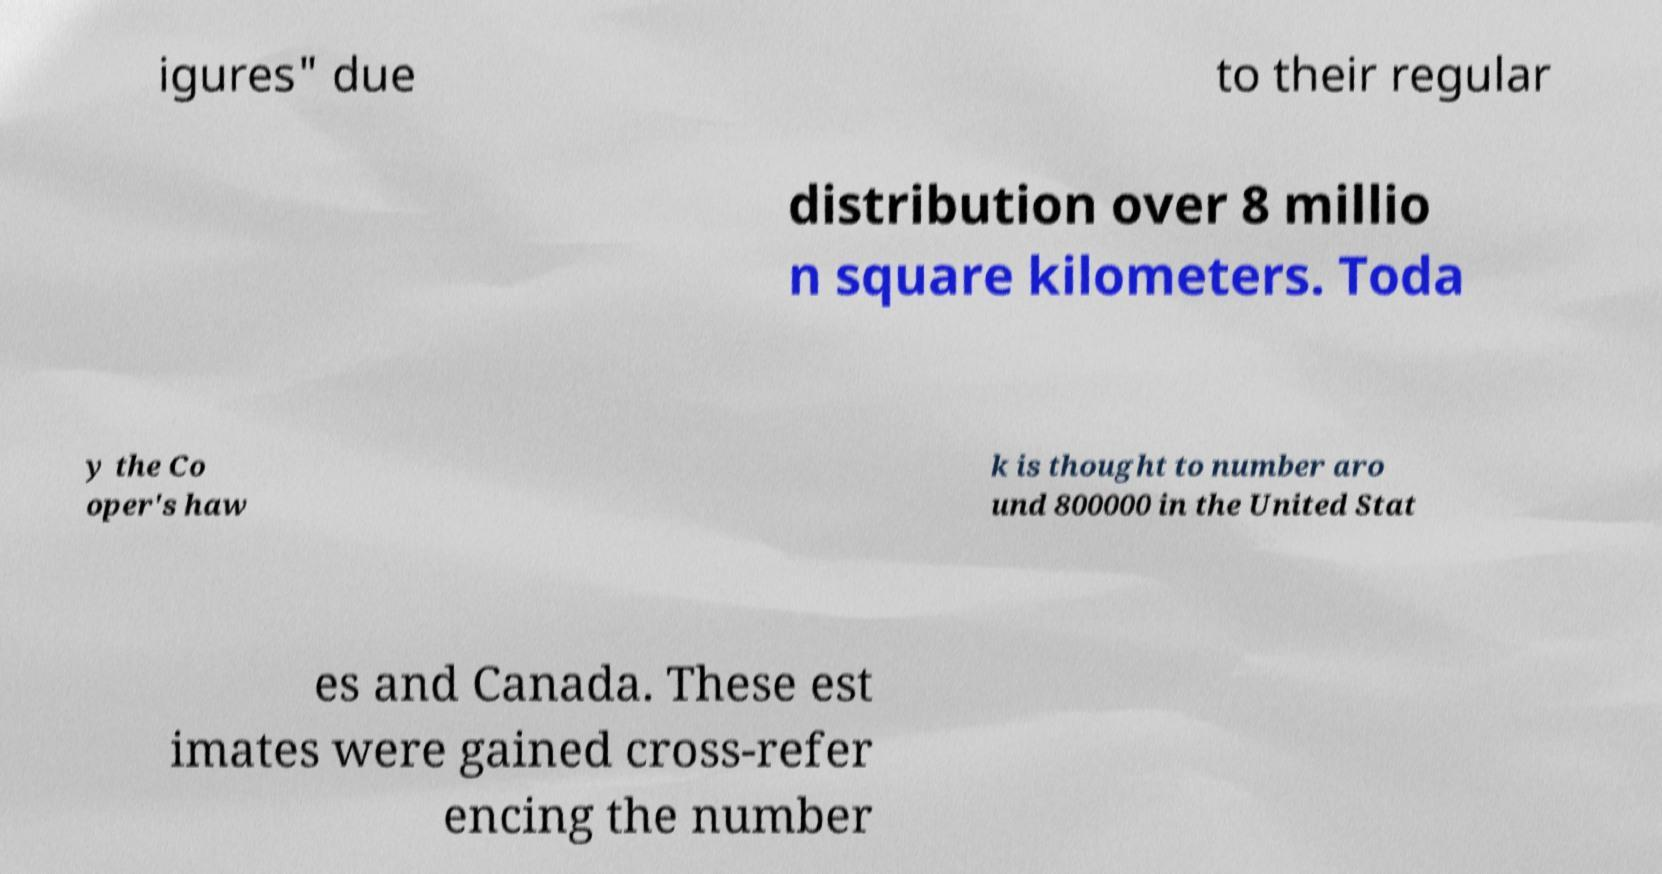Please identify and transcribe the text found in this image. igures" due to their regular distribution over 8 millio n square kilometers. Toda y the Co oper's haw k is thought to number aro und 800000 in the United Stat es and Canada. These est imates were gained cross-refer encing the number 